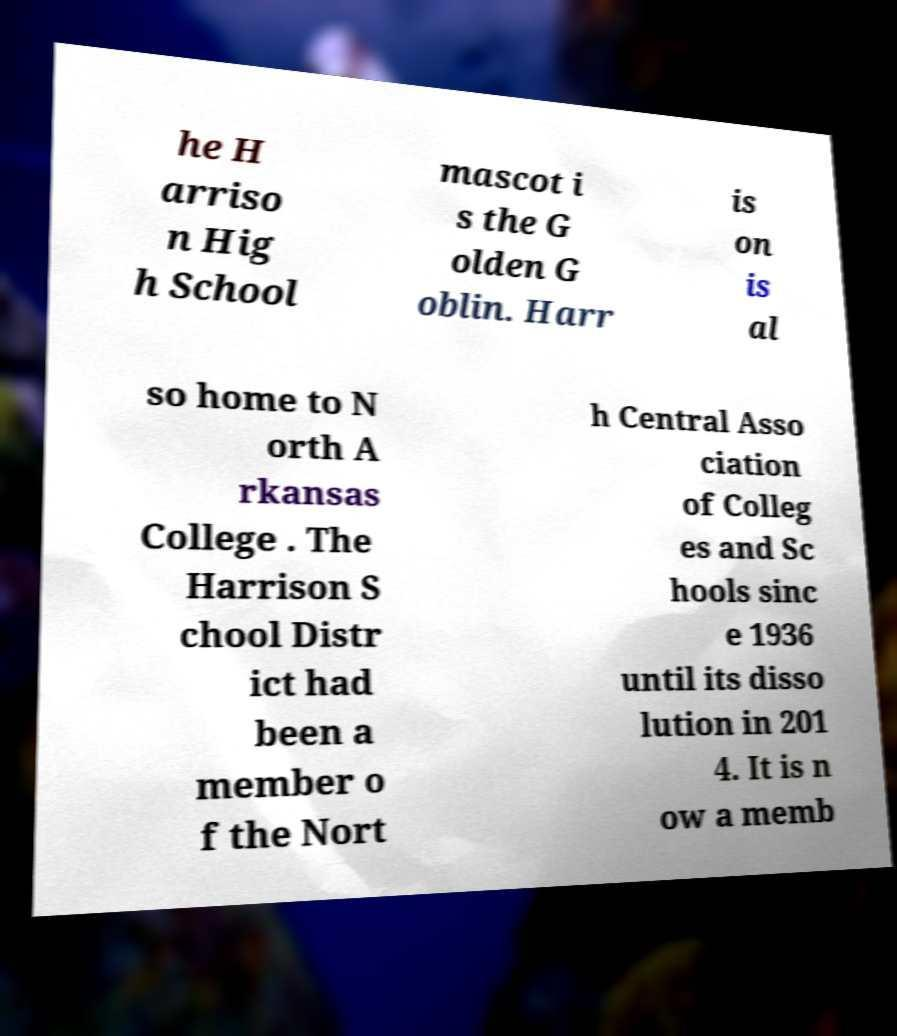Please read and relay the text visible in this image. What does it say? he H arriso n Hig h School mascot i s the G olden G oblin. Harr is on is al so home to N orth A rkansas College . The Harrison S chool Distr ict had been a member o f the Nort h Central Asso ciation of Colleg es and Sc hools sinc e 1936 until its disso lution in 201 4. It is n ow a memb 